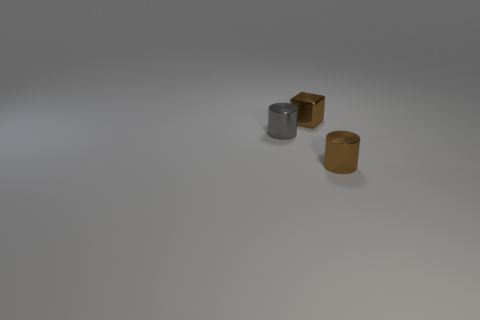Add 3 brown things. How many objects exist? 6 Subtract all brown cylinders. How many cylinders are left? 1 Subtract 1 cylinders. How many cylinders are left? 1 Subtract all blocks. How many objects are left? 2 Subtract all blue cylinders. Subtract all red balls. How many cylinders are left? 2 Subtract all gray objects. Subtract all tiny gray objects. How many objects are left? 1 Add 3 tiny gray metallic cylinders. How many tiny gray metallic cylinders are left? 4 Add 3 tiny brown metal cylinders. How many tiny brown metal cylinders exist? 4 Subtract 0 yellow cubes. How many objects are left? 3 